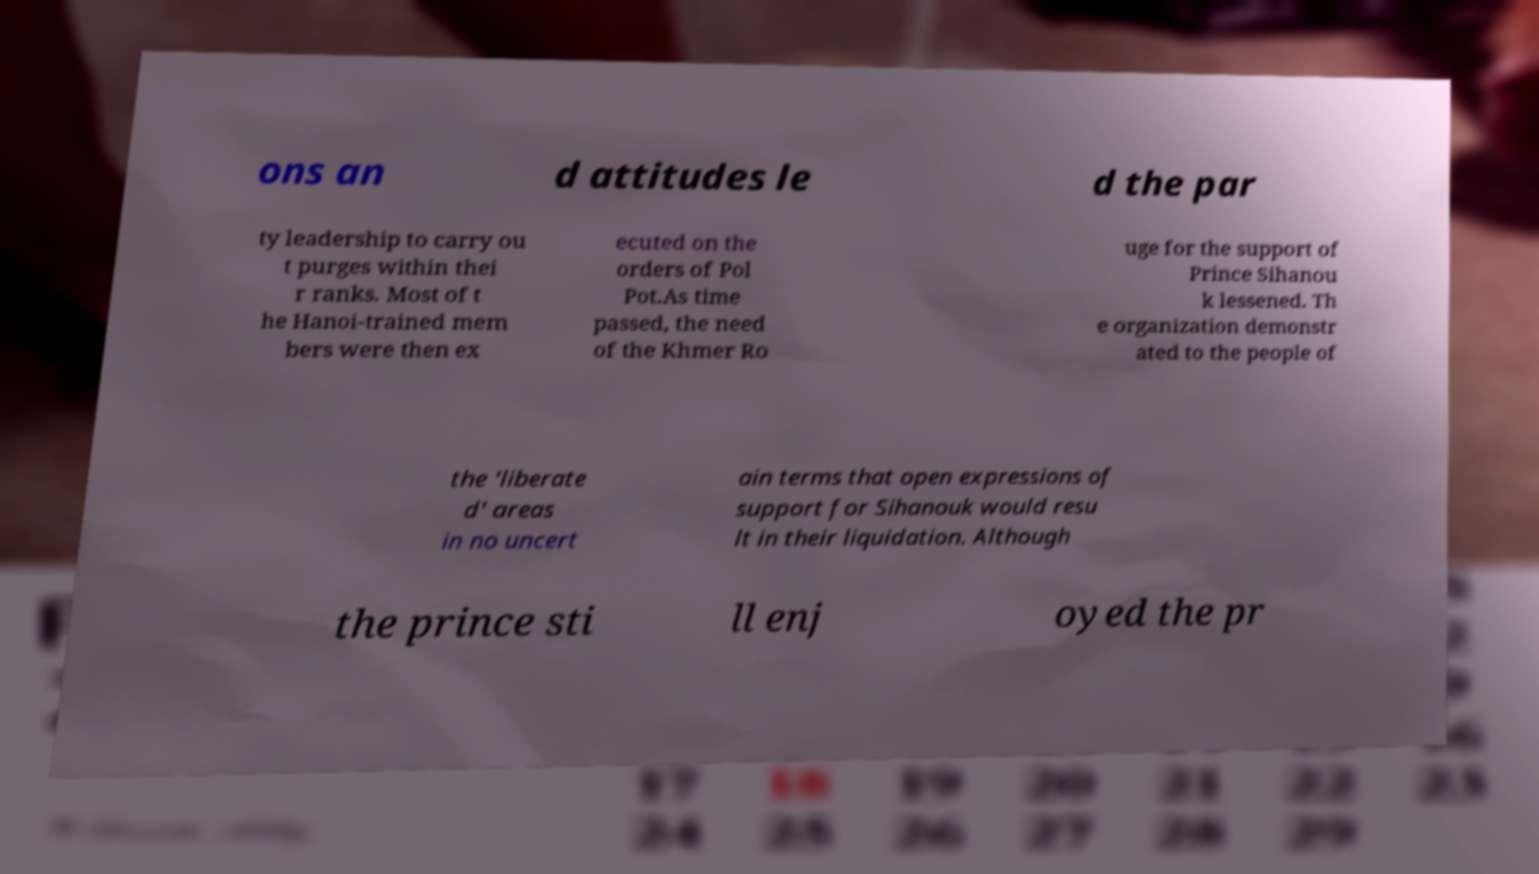For documentation purposes, I need the text within this image transcribed. Could you provide that? ons an d attitudes le d the par ty leadership to carry ou t purges within thei r ranks. Most of t he Hanoi-trained mem bers were then ex ecuted on the orders of Pol Pot.As time passed, the need of the Khmer Ro uge for the support of Prince Sihanou k lessened. Th e organization demonstr ated to the people of the 'liberate d' areas in no uncert ain terms that open expressions of support for Sihanouk would resu lt in their liquidation. Although the prince sti ll enj oyed the pr 